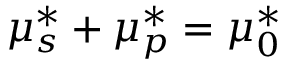Convert formula to latex. <formula><loc_0><loc_0><loc_500><loc_500>\mu _ { s } ^ { * } + \mu _ { p } ^ { * } = \mu _ { 0 } ^ { * }</formula> 